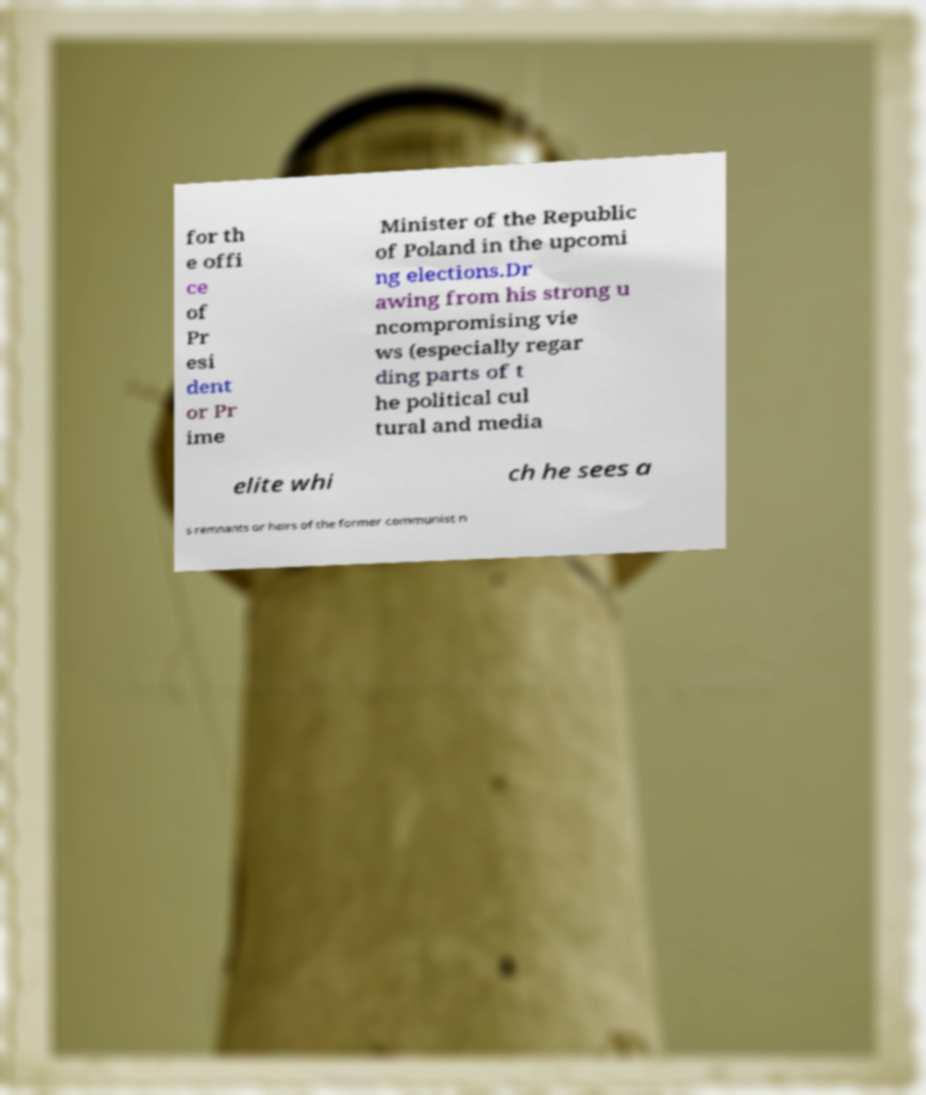Can you read and provide the text displayed in the image?This photo seems to have some interesting text. Can you extract and type it out for me? for th e offi ce of Pr esi dent or Pr ime Minister of the Republic of Poland in the upcomi ng elections.Dr awing from his strong u ncompromising vie ws (especially regar ding parts of t he political cul tural and media elite whi ch he sees a s remnants or heirs of the former communist n 